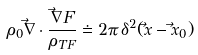<formula> <loc_0><loc_0><loc_500><loc_500>\rho _ { 0 } \vec { \nabla } \cdot \frac { \vec { \nabla } F } { \rho _ { T F } } \doteq 2 \pi \, \delta ^ { 2 } ( \vec { x } - \vec { x } _ { 0 } ) \,</formula> 